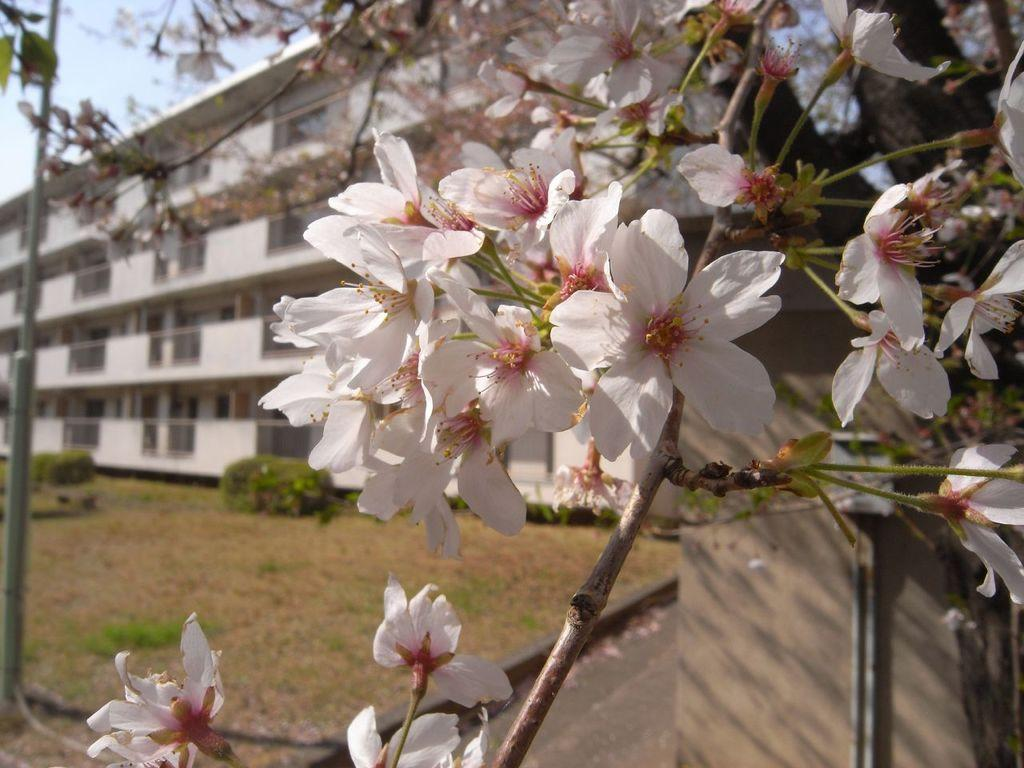What type of flora can be seen in the image? There are flowers and plants visible in the image. What structures are present in the background of the image? There is a building, a pole, and a wall in the background of the image. What natural elements can be seen in the background of the image? Branches and the sky are visible in the background of the image. How many boys are using their legs to aid in digestion in the image? There are no boys or references to digestion present in the image. 